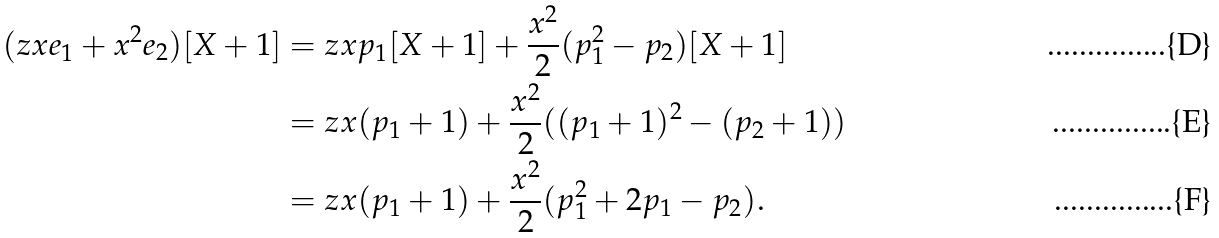Convert formula to latex. <formula><loc_0><loc_0><loc_500><loc_500>( z x e _ { 1 } + x ^ { 2 } e _ { 2 } ) [ X + 1 ] & = z x p _ { 1 } [ X + 1 ] + \frac { x ^ { 2 } } { 2 } ( p _ { 1 } ^ { 2 } - p _ { 2 } ) [ X + 1 ] \\ & = z x ( p _ { 1 } + 1 ) + \frac { x ^ { 2 } } { 2 } ( ( p _ { 1 } + 1 ) ^ { 2 } - ( p _ { 2 } + 1 ) ) \\ & = z x ( p _ { 1 } + 1 ) + \frac { x ^ { 2 } } { 2 } ( p _ { 1 } ^ { 2 } + 2 p _ { 1 } - p _ { 2 } ) .</formula> 